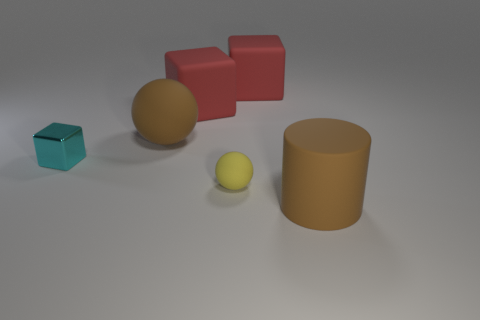Subtract all big blocks. How many blocks are left? 1 Subtract 3 cubes. How many cubes are left? 0 Subtract all red cylinders. How many red cubes are left? 2 Subtract all cyan blocks. How many blocks are left? 2 Add 2 cyan metal cubes. How many objects exist? 8 Subtract all cylinders. How many objects are left? 5 Subtract all red cylinders. Subtract all purple blocks. How many cylinders are left? 1 Subtract all purple metal cubes. Subtract all metal things. How many objects are left? 5 Add 2 red things. How many red things are left? 4 Add 1 brown rubber balls. How many brown rubber balls exist? 2 